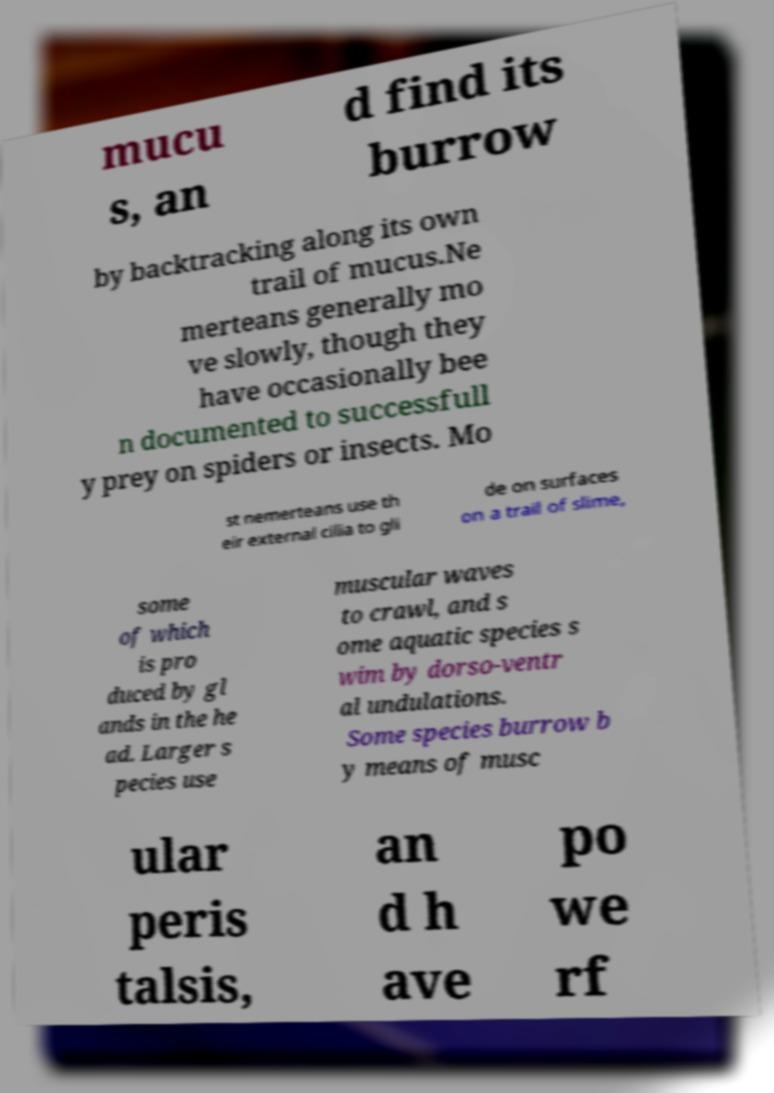Can you read and provide the text displayed in the image?This photo seems to have some interesting text. Can you extract and type it out for me? mucu s, an d find its burrow by backtracking along its own trail of mucus.Ne merteans generally mo ve slowly, though they have occasionally bee n documented to successfull y prey on spiders or insects. Mo st nemerteans use th eir external cilia to gli de on surfaces on a trail of slime, some of which is pro duced by gl ands in the he ad. Larger s pecies use muscular waves to crawl, and s ome aquatic species s wim by dorso-ventr al undulations. Some species burrow b y means of musc ular peris talsis, an d h ave po we rf 